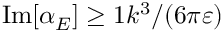Convert formula to latex. <formula><loc_0><loc_0><loc_500><loc_500>I m [ \alpha _ { E } ] \geq 1 k ^ { 3 } / ( 6 \pi \varepsilon )</formula> 